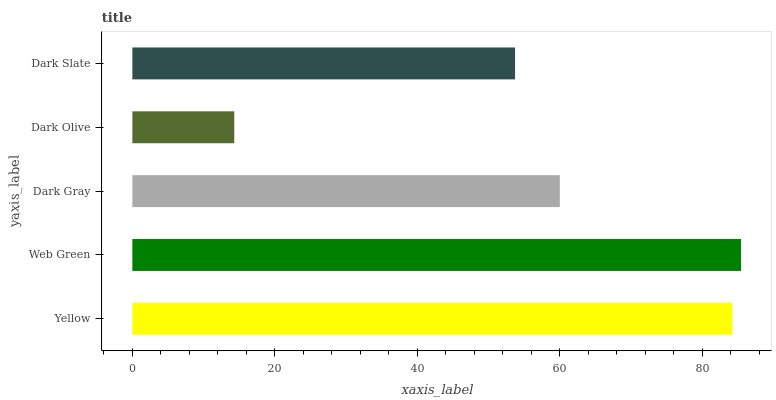Is Dark Olive the minimum?
Answer yes or no. Yes. Is Web Green the maximum?
Answer yes or no. Yes. Is Dark Gray the minimum?
Answer yes or no. No. Is Dark Gray the maximum?
Answer yes or no. No. Is Web Green greater than Dark Gray?
Answer yes or no. Yes. Is Dark Gray less than Web Green?
Answer yes or no. Yes. Is Dark Gray greater than Web Green?
Answer yes or no. No. Is Web Green less than Dark Gray?
Answer yes or no. No. Is Dark Gray the high median?
Answer yes or no. Yes. Is Dark Gray the low median?
Answer yes or no. Yes. Is Dark Olive the high median?
Answer yes or no. No. Is Web Green the low median?
Answer yes or no. No. 